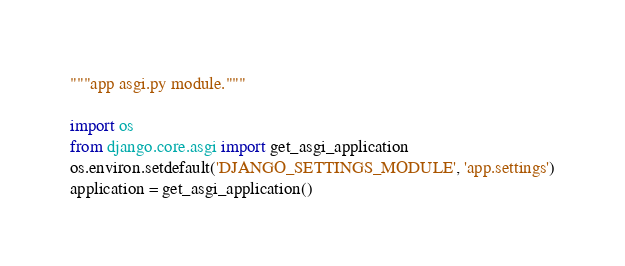Convert code to text. <code><loc_0><loc_0><loc_500><loc_500><_Python_>"""app asgi.py module."""

import os
from django.core.asgi import get_asgi_application
os.environ.setdefault('DJANGO_SETTINGS_MODULE', 'app.settings')
application = get_asgi_application()
</code> 